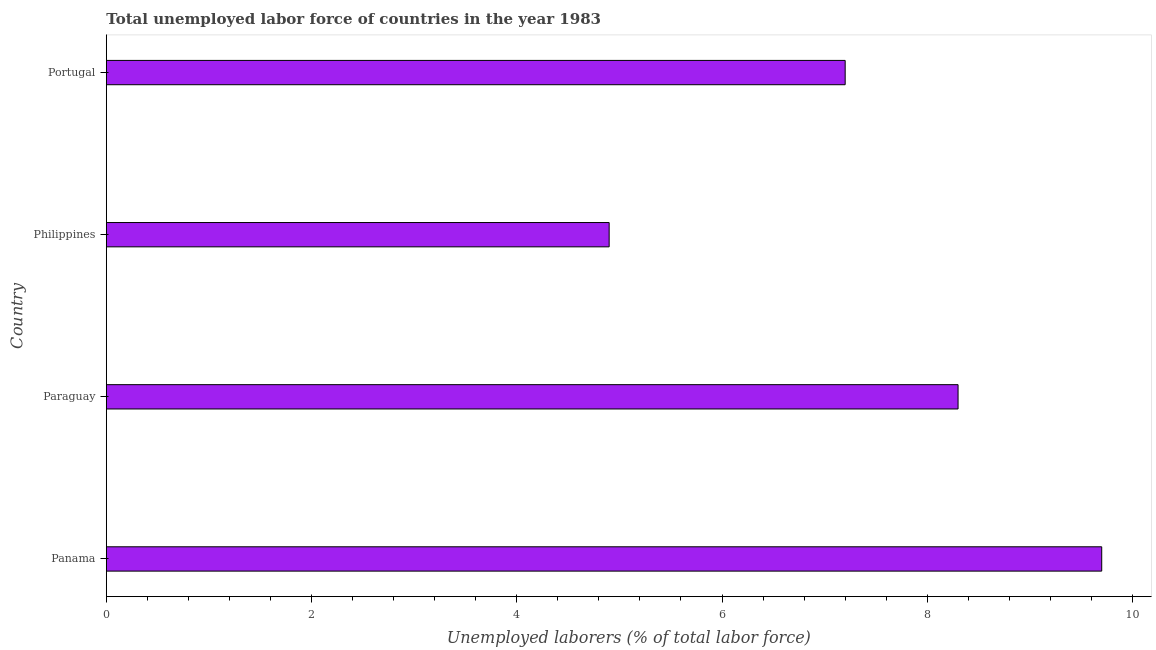Does the graph contain grids?
Provide a short and direct response. No. What is the title of the graph?
Make the answer very short. Total unemployed labor force of countries in the year 1983. What is the label or title of the X-axis?
Offer a terse response. Unemployed laborers (% of total labor force). What is the total unemployed labour force in Panama?
Offer a terse response. 9.7. Across all countries, what is the maximum total unemployed labour force?
Provide a succinct answer. 9.7. Across all countries, what is the minimum total unemployed labour force?
Provide a short and direct response. 4.9. In which country was the total unemployed labour force maximum?
Offer a very short reply. Panama. What is the sum of the total unemployed labour force?
Offer a very short reply. 30.1. What is the difference between the total unemployed labour force in Panama and Philippines?
Offer a very short reply. 4.8. What is the average total unemployed labour force per country?
Keep it short and to the point. 7.53. What is the median total unemployed labour force?
Offer a terse response. 7.75. What is the ratio of the total unemployed labour force in Panama to that in Philippines?
Your answer should be compact. 1.98. Is the total unemployed labour force in Panama less than that in Philippines?
Offer a very short reply. No. Is the difference between the total unemployed labour force in Paraguay and Philippines greater than the difference between any two countries?
Offer a very short reply. No. What is the difference between the highest and the second highest total unemployed labour force?
Ensure brevity in your answer.  1.4. Is the sum of the total unemployed labour force in Panama and Philippines greater than the maximum total unemployed labour force across all countries?
Keep it short and to the point. Yes. What is the difference between the highest and the lowest total unemployed labour force?
Ensure brevity in your answer.  4.8. In how many countries, is the total unemployed labour force greater than the average total unemployed labour force taken over all countries?
Make the answer very short. 2. Are all the bars in the graph horizontal?
Your response must be concise. Yes. What is the Unemployed laborers (% of total labor force) in Panama?
Provide a succinct answer. 9.7. What is the Unemployed laborers (% of total labor force) in Paraguay?
Provide a short and direct response. 8.3. What is the Unemployed laborers (% of total labor force) in Philippines?
Provide a succinct answer. 4.9. What is the Unemployed laborers (% of total labor force) of Portugal?
Ensure brevity in your answer.  7.2. What is the difference between the Unemployed laborers (% of total labor force) in Panama and Philippines?
Your answer should be very brief. 4.8. What is the difference between the Unemployed laborers (% of total labor force) in Paraguay and Philippines?
Keep it short and to the point. 3.4. What is the ratio of the Unemployed laborers (% of total labor force) in Panama to that in Paraguay?
Offer a very short reply. 1.17. What is the ratio of the Unemployed laborers (% of total labor force) in Panama to that in Philippines?
Offer a terse response. 1.98. What is the ratio of the Unemployed laborers (% of total labor force) in Panama to that in Portugal?
Make the answer very short. 1.35. What is the ratio of the Unemployed laborers (% of total labor force) in Paraguay to that in Philippines?
Offer a very short reply. 1.69. What is the ratio of the Unemployed laborers (% of total labor force) in Paraguay to that in Portugal?
Your response must be concise. 1.15. What is the ratio of the Unemployed laborers (% of total labor force) in Philippines to that in Portugal?
Make the answer very short. 0.68. 